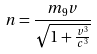<formula> <loc_0><loc_0><loc_500><loc_500>n = \frac { m _ { 9 } v } { \sqrt { 1 + \frac { v ^ { 3 } } { c ^ { 3 } } } }</formula> 